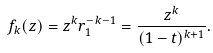<formula> <loc_0><loc_0><loc_500><loc_500>f _ { k } ( z ) = z ^ { k } r _ { 1 } ^ { - k - 1 } = \frac { z ^ { k } } { ( 1 - t ) ^ { k + 1 } } .</formula> 